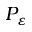Convert formula to latex. <formula><loc_0><loc_0><loc_500><loc_500>P _ { \varepsilon }</formula> 